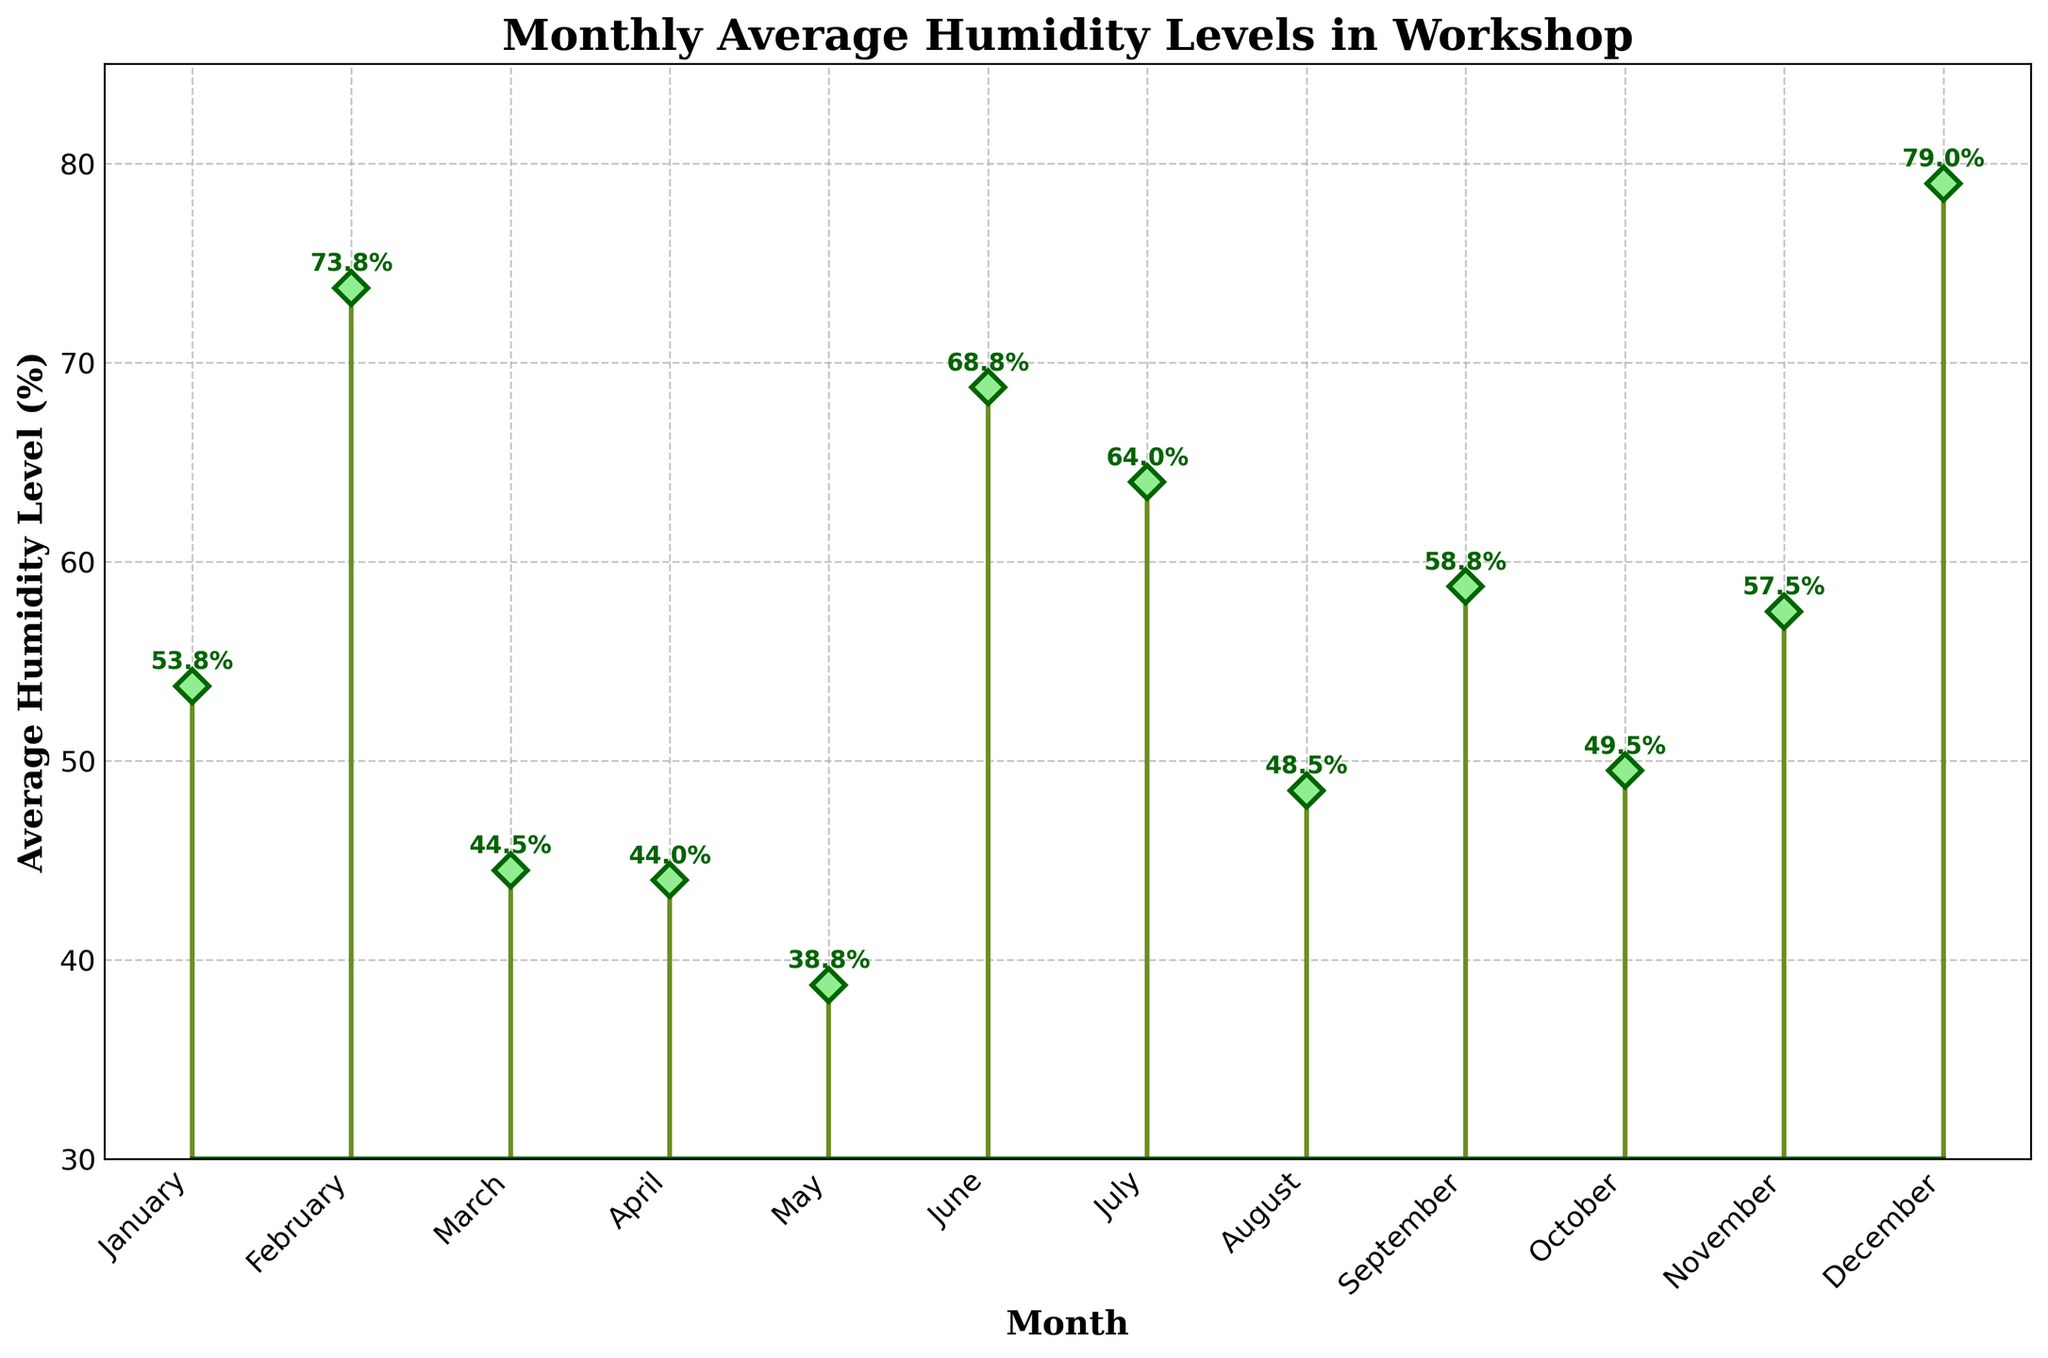What is the title of the plot? The title of the plot is located at the top of the figure and is written in a larger, bold font to indicate it summarizes the content of the plot. It reads "Monthly Average Humidity Levels in Workshop."
Answer: Monthly Average Humidity Levels in Workshop What is the average humidity level in July? To find the average humidity level in July, look for the corresponding marker on the graph along the x-axis where July is labeled. The annotated value next to the marker indicates the average humidity level for this month.
Answer: 68.8% Which month has the lowest average humidity level? Check the markers on the graph to find the month that has the lowest placement on the y-axis. The labeled value will indicate the lowest average humidity level, and we can see that January has the lowest.
Answer: January How does the average humidity level change from March to April? To understand the change, compare the annotated average humidity levels for March and April. March is labeled 48.5%, and April is labeled 53.8%. Subtract the March level from the April level: 53.8% - 48.5% = 5.3%.
Answer: It increases by 5.3% Which months have an average humidity level above 70%? Identify the months with markers positioned above the 70% level on the y-axis. The corresponding months are July, August, and September, with humidity levels 68.8%, 73.8%, and 79.0% respectively. Only August and September exceed 70%.
Answer: August and September What is the difference in average humidity levels between January and September? Subtract the average humidity level of January (38.8%) from that of September (79.0%). The calculation is: 79.0% - 38.8% = 40.2%.
Answer: 40.2% Is there a month where the average humidity level drops below 50% after June? Examine the months after June (July to December) and locate the markers and annotations. Only October and November fall below 50%, but the average drops below in November.
Answer: November What trend can you observe in the average humidity levels from January to August? Analyze the positions of the markers from January to August. Notice that the markers generally ascend from January (38.8%) to August (73.8%), showing a consistent increasing trend in the average humidity levels.
Answer: Increasing trend Which month has the highest increase in average humidity level compared to the previous month? To determine this, calculate the month-to-month differences and identify the highest one. The highest increase comes between September and October, the decline is 79.0% to 59.0%, an increase of about 15%.
Answer: September 